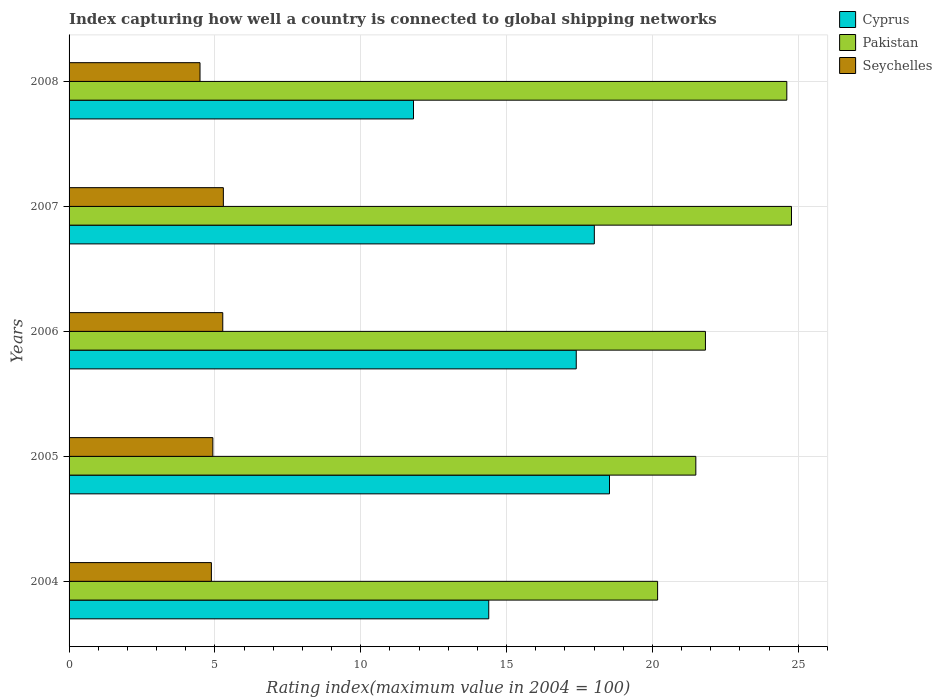How many groups of bars are there?
Ensure brevity in your answer.  5. Are the number of bars per tick equal to the number of legend labels?
Your answer should be very brief. Yes. How many bars are there on the 3rd tick from the top?
Ensure brevity in your answer.  3. In how many cases, is the number of bars for a given year not equal to the number of legend labels?
Provide a succinct answer. 0. What is the rating index in Seychelles in 2005?
Keep it short and to the point. 4.93. Across all years, what is the maximum rating index in Cyprus?
Your answer should be very brief. 18.53. Across all years, what is the minimum rating index in Seychelles?
Your response must be concise. 4.49. What is the total rating index in Seychelles in the graph?
Your response must be concise. 24.86. What is the difference between the rating index in Pakistan in 2007 and that in 2008?
Provide a short and direct response. 0.16. What is the difference between the rating index in Seychelles in 2005 and the rating index in Cyprus in 2008?
Your answer should be compact. -6.88. What is the average rating index in Seychelles per year?
Provide a succinct answer. 4.97. In the year 2006, what is the difference between the rating index in Seychelles and rating index in Cyprus?
Your answer should be compact. -12.12. In how many years, is the rating index in Pakistan greater than 15 ?
Your answer should be very brief. 5. What is the ratio of the rating index in Cyprus in 2006 to that in 2008?
Make the answer very short. 1.47. What is the difference between the highest and the second highest rating index in Cyprus?
Give a very brief answer. 0.52. What is the difference between the highest and the lowest rating index in Pakistan?
Give a very brief answer. 4.59. In how many years, is the rating index in Cyprus greater than the average rating index in Cyprus taken over all years?
Offer a very short reply. 3. What does the 1st bar from the top in 2006 represents?
Your response must be concise. Seychelles. What does the 1st bar from the bottom in 2005 represents?
Provide a succinct answer. Cyprus. Are all the bars in the graph horizontal?
Provide a short and direct response. Yes. Does the graph contain grids?
Offer a terse response. Yes. Where does the legend appear in the graph?
Your answer should be very brief. Top right. What is the title of the graph?
Offer a terse response. Index capturing how well a country is connected to global shipping networks. Does "Australia" appear as one of the legend labels in the graph?
Your response must be concise. No. What is the label or title of the X-axis?
Offer a terse response. Rating index(maximum value in 2004 = 100). What is the label or title of the Y-axis?
Offer a terse response. Years. What is the Rating index(maximum value in 2004 = 100) of Cyprus in 2004?
Offer a terse response. 14.39. What is the Rating index(maximum value in 2004 = 100) of Pakistan in 2004?
Provide a short and direct response. 20.18. What is the Rating index(maximum value in 2004 = 100) of Seychelles in 2004?
Your answer should be compact. 4.88. What is the Rating index(maximum value in 2004 = 100) in Cyprus in 2005?
Give a very brief answer. 18.53. What is the Rating index(maximum value in 2004 = 100) of Pakistan in 2005?
Ensure brevity in your answer.  21.49. What is the Rating index(maximum value in 2004 = 100) of Seychelles in 2005?
Your response must be concise. 4.93. What is the Rating index(maximum value in 2004 = 100) of Cyprus in 2006?
Give a very brief answer. 17.39. What is the Rating index(maximum value in 2004 = 100) of Pakistan in 2006?
Offer a very short reply. 21.82. What is the Rating index(maximum value in 2004 = 100) in Seychelles in 2006?
Make the answer very short. 5.27. What is the Rating index(maximum value in 2004 = 100) in Cyprus in 2007?
Make the answer very short. 18.01. What is the Rating index(maximum value in 2004 = 100) of Pakistan in 2007?
Your answer should be very brief. 24.77. What is the Rating index(maximum value in 2004 = 100) in Seychelles in 2007?
Provide a short and direct response. 5.29. What is the Rating index(maximum value in 2004 = 100) in Cyprus in 2008?
Your response must be concise. 11.81. What is the Rating index(maximum value in 2004 = 100) in Pakistan in 2008?
Your answer should be compact. 24.61. What is the Rating index(maximum value in 2004 = 100) in Seychelles in 2008?
Your answer should be compact. 4.49. Across all years, what is the maximum Rating index(maximum value in 2004 = 100) of Cyprus?
Your answer should be compact. 18.53. Across all years, what is the maximum Rating index(maximum value in 2004 = 100) of Pakistan?
Ensure brevity in your answer.  24.77. Across all years, what is the maximum Rating index(maximum value in 2004 = 100) of Seychelles?
Your response must be concise. 5.29. Across all years, what is the minimum Rating index(maximum value in 2004 = 100) of Cyprus?
Make the answer very short. 11.81. Across all years, what is the minimum Rating index(maximum value in 2004 = 100) of Pakistan?
Provide a short and direct response. 20.18. Across all years, what is the minimum Rating index(maximum value in 2004 = 100) of Seychelles?
Make the answer very short. 4.49. What is the total Rating index(maximum value in 2004 = 100) of Cyprus in the graph?
Make the answer very short. 80.13. What is the total Rating index(maximum value in 2004 = 100) in Pakistan in the graph?
Your answer should be very brief. 112.87. What is the total Rating index(maximum value in 2004 = 100) in Seychelles in the graph?
Your answer should be very brief. 24.86. What is the difference between the Rating index(maximum value in 2004 = 100) of Cyprus in 2004 and that in 2005?
Your answer should be very brief. -4.14. What is the difference between the Rating index(maximum value in 2004 = 100) of Pakistan in 2004 and that in 2005?
Give a very brief answer. -1.31. What is the difference between the Rating index(maximum value in 2004 = 100) in Pakistan in 2004 and that in 2006?
Your answer should be compact. -1.64. What is the difference between the Rating index(maximum value in 2004 = 100) of Seychelles in 2004 and that in 2006?
Offer a terse response. -0.39. What is the difference between the Rating index(maximum value in 2004 = 100) in Cyprus in 2004 and that in 2007?
Your answer should be very brief. -3.62. What is the difference between the Rating index(maximum value in 2004 = 100) in Pakistan in 2004 and that in 2007?
Give a very brief answer. -4.59. What is the difference between the Rating index(maximum value in 2004 = 100) in Seychelles in 2004 and that in 2007?
Give a very brief answer. -0.41. What is the difference between the Rating index(maximum value in 2004 = 100) in Cyprus in 2004 and that in 2008?
Provide a succinct answer. 2.58. What is the difference between the Rating index(maximum value in 2004 = 100) in Pakistan in 2004 and that in 2008?
Keep it short and to the point. -4.43. What is the difference between the Rating index(maximum value in 2004 = 100) of Seychelles in 2004 and that in 2008?
Provide a succinct answer. 0.39. What is the difference between the Rating index(maximum value in 2004 = 100) in Cyprus in 2005 and that in 2006?
Offer a very short reply. 1.14. What is the difference between the Rating index(maximum value in 2004 = 100) in Pakistan in 2005 and that in 2006?
Provide a short and direct response. -0.33. What is the difference between the Rating index(maximum value in 2004 = 100) of Seychelles in 2005 and that in 2006?
Give a very brief answer. -0.34. What is the difference between the Rating index(maximum value in 2004 = 100) in Cyprus in 2005 and that in 2007?
Keep it short and to the point. 0.52. What is the difference between the Rating index(maximum value in 2004 = 100) in Pakistan in 2005 and that in 2007?
Keep it short and to the point. -3.28. What is the difference between the Rating index(maximum value in 2004 = 100) of Seychelles in 2005 and that in 2007?
Make the answer very short. -0.36. What is the difference between the Rating index(maximum value in 2004 = 100) in Cyprus in 2005 and that in 2008?
Give a very brief answer. 6.72. What is the difference between the Rating index(maximum value in 2004 = 100) of Pakistan in 2005 and that in 2008?
Your answer should be compact. -3.12. What is the difference between the Rating index(maximum value in 2004 = 100) of Seychelles in 2005 and that in 2008?
Give a very brief answer. 0.44. What is the difference between the Rating index(maximum value in 2004 = 100) of Cyprus in 2006 and that in 2007?
Give a very brief answer. -0.62. What is the difference between the Rating index(maximum value in 2004 = 100) in Pakistan in 2006 and that in 2007?
Your answer should be compact. -2.95. What is the difference between the Rating index(maximum value in 2004 = 100) of Seychelles in 2006 and that in 2007?
Your answer should be compact. -0.02. What is the difference between the Rating index(maximum value in 2004 = 100) of Cyprus in 2006 and that in 2008?
Your answer should be compact. 5.58. What is the difference between the Rating index(maximum value in 2004 = 100) of Pakistan in 2006 and that in 2008?
Provide a succinct answer. -2.79. What is the difference between the Rating index(maximum value in 2004 = 100) of Seychelles in 2006 and that in 2008?
Your answer should be compact. 0.78. What is the difference between the Rating index(maximum value in 2004 = 100) of Cyprus in 2007 and that in 2008?
Your response must be concise. 6.2. What is the difference between the Rating index(maximum value in 2004 = 100) of Pakistan in 2007 and that in 2008?
Make the answer very short. 0.16. What is the difference between the Rating index(maximum value in 2004 = 100) in Cyprus in 2004 and the Rating index(maximum value in 2004 = 100) in Seychelles in 2005?
Provide a succinct answer. 9.46. What is the difference between the Rating index(maximum value in 2004 = 100) of Pakistan in 2004 and the Rating index(maximum value in 2004 = 100) of Seychelles in 2005?
Your answer should be compact. 15.25. What is the difference between the Rating index(maximum value in 2004 = 100) in Cyprus in 2004 and the Rating index(maximum value in 2004 = 100) in Pakistan in 2006?
Ensure brevity in your answer.  -7.43. What is the difference between the Rating index(maximum value in 2004 = 100) of Cyprus in 2004 and the Rating index(maximum value in 2004 = 100) of Seychelles in 2006?
Provide a succinct answer. 9.12. What is the difference between the Rating index(maximum value in 2004 = 100) of Pakistan in 2004 and the Rating index(maximum value in 2004 = 100) of Seychelles in 2006?
Your answer should be compact. 14.91. What is the difference between the Rating index(maximum value in 2004 = 100) in Cyprus in 2004 and the Rating index(maximum value in 2004 = 100) in Pakistan in 2007?
Ensure brevity in your answer.  -10.38. What is the difference between the Rating index(maximum value in 2004 = 100) in Pakistan in 2004 and the Rating index(maximum value in 2004 = 100) in Seychelles in 2007?
Your answer should be very brief. 14.89. What is the difference between the Rating index(maximum value in 2004 = 100) of Cyprus in 2004 and the Rating index(maximum value in 2004 = 100) of Pakistan in 2008?
Make the answer very short. -10.22. What is the difference between the Rating index(maximum value in 2004 = 100) of Cyprus in 2004 and the Rating index(maximum value in 2004 = 100) of Seychelles in 2008?
Make the answer very short. 9.9. What is the difference between the Rating index(maximum value in 2004 = 100) in Pakistan in 2004 and the Rating index(maximum value in 2004 = 100) in Seychelles in 2008?
Your response must be concise. 15.69. What is the difference between the Rating index(maximum value in 2004 = 100) of Cyprus in 2005 and the Rating index(maximum value in 2004 = 100) of Pakistan in 2006?
Your response must be concise. -3.29. What is the difference between the Rating index(maximum value in 2004 = 100) in Cyprus in 2005 and the Rating index(maximum value in 2004 = 100) in Seychelles in 2006?
Provide a short and direct response. 13.26. What is the difference between the Rating index(maximum value in 2004 = 100) in Pakistan in 2005 and the Rating index(maximum value in 2004 = 100) in Seychelles in 2006?
Your answer should be very brief. 16.22. What is the difference between the Rating index(maximum value in 2004 = 100) of Cyprus in 2005 and the Rating index(maximum value in 2004 = 100) of Pakistan in 2007?
Your response must be concise. -6.24. What is the difference between the Rating index(maximum value in 2004 = 100) of Cyprus in 2005 and the Rating index(maximum value in 2004 = 100) of Seychelles in 2007?
Offer a terse response. 13.24. What is the difference between the Rating index(maximum value in 2004 = 100) in Cyprus in 2005 and the Rating index(maximum value in 2004 = 100) in Pakistan in 2008?
Provide a succinct answer. -6.08. What is the difference between the Rating index(maximum value in 2004 = 100) of Cyprus in 2005 and the Rating index(maximum value in 2004 = 100) of Seychelles in 2008?
Give a very brief answer. 14.04. What is the difference between the Rating index(maximum value in 2004 = 100) in Cyprus in 2006 and the Rating index(maximum value in 2004 = 100) in Pakistan in 2007?
Provide a succinct answer. -7.38. What is the difference between the Rating index(maximum value in 2004 = 100) of Cyprus in 2006 and the Rating index(maximum value in 2004 = 100) of Seychelles in 2007?
Your answer should be compact. 12.1. What is the difference between the Rating index(maximum value in 2004 = 100) of Pakistan in 2006 and the Rating index(maximum value in 2004 = 100) of Seychelles in 2007?
Ensure brevity in your answer.  16.53. What is the difference between the Rating index(maximum value in 2004 = 100) in Cyprus in 2006 and the Rating index(maximum value in 2004 = 100) in Pakistan in 2008?
Your response must be concise. -7.22. What is the difference between the Rating index(maximum value in 2004 = 100) of Cyprus in 2006 and the Rating index(maximum value in 2004 = 100) of Seychelles in 2008?
Your response must be concise. 12.9. What is the difference between the Rating index(maximum value in 2004 = 100) of Pakistan in 2006 and the Rating index(maximum value in 2004 = 100) of Seychelles in 2008?
Ensure brevity in your answer.  17.33. What is the difference between the Rating index(maximum value in 2004 = 100) of Cyprus in 2007 and the Rating index(maximum value in 2004 = 100) of Pakistan in 2008?
Your answer should be very brief. -6.6. What is the difference between the Rating index(maximum value in 2004 = 100) in Cyprus in 2007 and the Rating index(maximum value in 2004 = 100) in Seychelles in 2008?
Your answer should be very brief. 13.52. What is the difference between the Rating index(maximum value in 2004 = 100) of Pakistan in 2007 and the Rating index(maximum value in 2004 = 100) of Seychelles in 2008?
Your answer should be compact. 20.28. What is the average Rating index(maximum value in 2004 = 100) of Cyprus per year?
Give a very brief answer. 16.03. What is the average Rating index(maximum value in 2004 = 100) of Pakistan per year?
Make the answer very short. 22.57. What is the average Rating index(maximum value in 2004 = 100) in Seychelles per year?
Your answer should be very brief. 4.97. In the year 2004, what is the difference between the Rating index(maximum value in 2004 = 100) of Cyprus and Rating index(maximum value in 2004 = 100) of Pakistan?
Give a very brief answer. -5.79. In the year 2004, what is the difference between the Rating index(maximum value in 2004 = 100) in Cyprus and Rating index(maximum value in 2004 = 100) in Seychelles?
Offer a very short reply. 9.51. In the year 2004, what is the difference between the Rating index(maximum value in 2004 = 100) of Pakistan and Rating index(maximum value in 2004 = 100) of Seychelles?
Your answer should be very brief. 15.3. In the year 2005, what is the difference between the Rating index(maximum value in 2004 = 100) in Cyprus and Rating index(maximum value in 2004 = 100) in Pakistan?
Your answer should be very brief. -2.96. In the year 2005, what is the difference between the Rating index(maximum value in 2004 = 100) of Cyprus and Rating index(maximum value in 2004 = 100) of Seychelles?
Offer a very short reply. 13.6. In the year 2005, what is the difference between the Rating index(maximum value in 2004 = 100) of Pakistan and Rating index(maximum value in 2004 = 100) of Seychelles?
Keep it short and to the point. 16.56. In the year 2006, what is the difference between the Rating index(maximum value in 2004 = 100) of Cyprus and Rating index(maximum value in 2004 = 100) of Pakistan?
Your answer should be very brief. -4.43. In the year 2006, what is the difference between the Rating index(maximum value in 2004 = 100) in Cyprus and Rating index(maximum value in 2004 = 100) in Seychelles?
Your answer should be compact. 12.12. In the year 2006, what is the difference between the Rating index(maximum value in 2004 = 100) of Pakistan and Rating index(maximum value in 2004 = 100) of Seychelles?
Your answer should be very brief. 16.55. In the year 2007, what is the difference between the Rating index(maximum value in 2004 = 100) in Cyprus and Rating index(maximum value in 2004 = 100) in Pakistan?
Offer a very short reply. -6.76. In the year 2007, what is the difference between the Rating index(maximum value in 2004 = 100) of Cyprus and Rating index(maximum value in 2004 = 100) of Seychelles?
Your response must be concise. 12.72. In the year 2007, what is the difference between the Rating index(maximum value in 2004 = 100) in Pakistan and Rating index(maximum value in 2004 = 100) in Seychelles?
Give a very brief answer. 19.48. In the year 2008, what is the difference between the Rating index(maximum value in 2004 = 100) of Cyprus and Rating index(maximum value in 2004 = 100) of Seychelles?
Offer a terse response. 7.32. In the year 2008, what is the difference between the Rating index(maximum value in 2004 = 100) in Pakistan and Rating index(maximum value in 2004 = 100) in Seychelles?
Make the answer very short. 20.12. What is the ratio of the Rating index(maximum value in 2004 = 100) in Cyprus in 2004 to that in 2005?
Offer a terse response. 0.78. What is the ratio of the Rating index(maximum value in 2004 = 100) in Pakistan in 2004 to that in 2005?
Your answer should be very brief. 0.94. What is the ratio of the Rating index(maximum value in 2004 = 100) in Seychelles in 2004 to that in 2005?
Give a very brief answer. 0.99. What is the ratio of the Rating index(maximum value in 2004 = 100) in Cyprus in 2004 to that in 2006?
Provide a succinct answer. 0.83. What is the ratio of the Rating index(maximum value in 2004 = 100) of Pakistan in 2004 to that in 2006?
Your answer should be very brief. 0.92. What is the ratio of the Rating index(maximum value in 2004 = 100) of Seychelles in 2004 to that in 2006?
Give a very brief answer. 0.93. What is the ratio of the Rating index(maximum value in 2004 = 100) in Cyprus in 2004 to that in 2007?
Give a very brief answer. 0.8. What is the ratio of the Rating index(maximum value in 2004 = 100) in Pakistan in 2004 to that in 2007?
Your answer should be very brief. 0.81. What is the ratio of the Rating index(maximum value in 2004 = 100) in Seychelles in 2004 to that in 2007?
Your answer should be very brief. 0.92. What is the ratio of the Rating index(maximum value in 2004 = 100) in Cyprus in 2004 to that in 2008?
Your answer should be very brief. 1.22. What is the ratio of the Rating index(maximum value in 2004 = 100) in Pakistan in 2004 to that in 2008?
Make the answer very short. 0.82. What is the ratio of the Rating index(maximum value in 2004 = 100) of Seychelles in 2004 to that in 2008?
Give a very brief answer. 1.09. What is the ratio of the Rating index(maximum value in 2004 = 100) of Cyprus in 2005 to that in 2006?
Your answer should be compact. 1.07. What is the ratio of the Rating index(maximum value in 2004 = 100) of Pakistan in 2005 to that in 2006?
Offer a terse response. 0.98. What is the ratio of the Rating index(maximum value in 2004 = 100) in Seychelles in 2005 to that in 2006?
Give a very brief answer. 0.94. What is the ratio of the Rating index(maximum value in 2004 = 100) in Cyprus in 2005 to that in 2007?
Your answer should be very brief. 1.03. What is the ratio of the Rating index(maximum value in 2004 = 100) of Pakistan in 2005 to that in 2007?
Provide a short and direct response. 0.87. What is the ratio of the Rating index(maximum value in 2004 = 100) in Seychelles in 2005 to that in 2007?
Provide a succinct answer. 0.93. What is the ratio of the Rating index(maximum value in 2004 = 100) of Cyprus in 2005 to that in 2008?
Your answer should be very brief. 1.57. What is the ratio of the Rating index(maximum value in 2004 = 100) in Pakistan in 2005 to that in 2008?
Provide a succinct answer. 0.87. What is the ratio of the Rating index(maximum value in 2004 = 100) in Seychelles in 2005 to that in 2008?
Your response must be concise. 1.1. What is the ratio of the Rating index(maximum value in 2004 = 100) of Cyprus in 2006 to that in 2007?
Offer a very short reply. 0.97. What is the ratio of the Rating index(maximum value in 2004 = 100) of Pakistan in 2006 to that in 2007?
Your response must be concise. 0.88. What is the ratio of the Rating index(maximum value in 2004 = 100) in Seychelles in 2006 to that in 2007?
Offer a terse response. 1. What is the ratio of the Rating index(maximum value in 2004 = 100) in Cyprus in 2006 to that in 2008?
Your answer should be compact. 1.47. What is the ratio of the Rating index(maximum value in 2004 = 100) of Pakistan in 2006 to that in 2008?
Offer a very short reply. 0.89. What is the ratio of the Rating index(maximum value in 2004 = 100) of Seychelles in 2006 to that in 2008?
Provide a short and direct response. 1.17. What is the ratio of the Rating index(maximum value in 2004 = 100) in Cyprus in 2007 to that in 2008?
Make the answer very short. 1.52. What is the ratio of the Rating index(maximum value in 2004 = 100) in Pakistan in 2007 to that in 2008?
Make the answer very short. 1.01. What is the ratio of the Rating index(maximum value in 2004 = 100) in Seychelles in 2007 to that in 2008?
Make the answer very short. 1.18. What is the difference between the highest and the second highest Rating index(maximum value in 2004 = 100) of Cyprus?
Offer a very short reply. 0.52. What is the difference between the highest and the second highest Rating index(maximum value in 2004 = 100) of Pakistan?
Provide a succinct answer. 0.16. What is the difference between the highest and the second highest Rating index(maximum value in 2004 = 100) in Seychelles?
Offer a terse response. 0.02. What is the difference between the highest and the lowest Rating index(maximum value in 2004 = 100) of Cyprus?
Make the answer very short. 6.72. What is the difference between the highest and the lowest Rating index(maximum value in 2004 = 100) of Pakistan?
Your answer should be very brief. 4.59. 